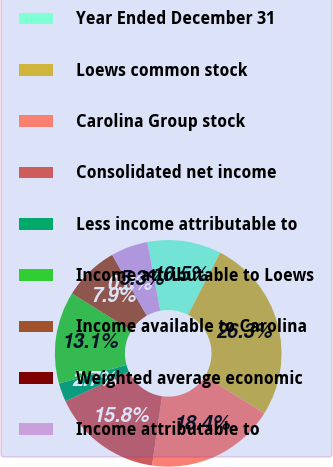Convert chart. <chart><loc_0><loc_0><loc_500><loc_500><pie_chart><fcel>Year Ended December 31<fcel>Loews common stock<fcel>Carolina Group stock<fcel>Consolidated net income<fcel>Less income attributable to<fcel>Income attributable to Loews<fcel>Income available to Carolina<fcel>Weighted average economic<fcel>Income attributable to<nl><fcel>10.53%<fcel>26.28%<fcel>18.41%<fcel>15.78%<fcel>2.65%<fcel>13.15%<fcel>7.9%<fcel>0.02%<fcel>5.28%<nl></chart> 